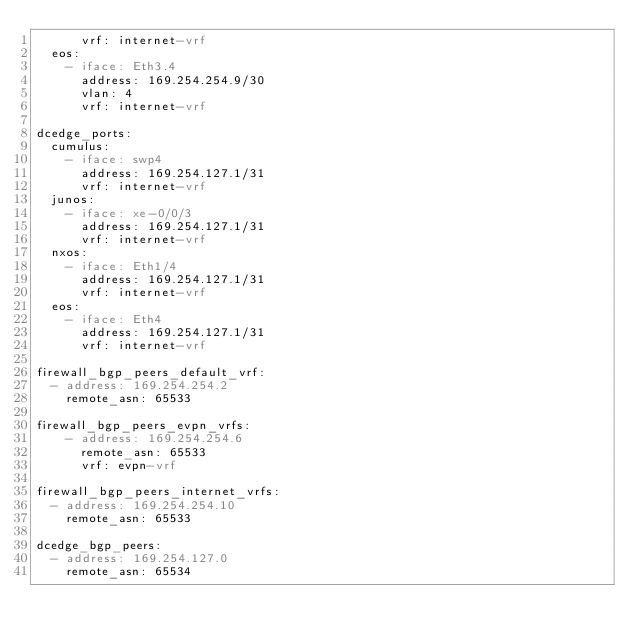<code> <loc_0><loc_0><loc_500><loc_500><_YAML_>      vrf: internet-vrf
  eos:
    - iface: Eth3.4
      address: 169.254.254.9/30
      vlan: 4
      vrf: internet-vrf

dcedge_ports:
  cumulus:
    - iface: swp4
      address: 169.254.127.1/31
      vrf: internet-vrf
  junos:
    - iface: xe-0/0/3
      address: 169.254.127.1/31
      vrf: internet-vrf
  nxos:
    - iface: Eth1/4
      address: 169.254.127.1/31
      vrf: internet-vrf
  eos:
    - iface: Eth4
      address: 169.254.127.1/31
      vrf: internet-vrf

firewall_bgp_peers_default_vrf:
  - address: 169.254.254.2
    remote_asn: 65533

firewall_bgp_peers_evpn_vrfs:
    - address: 169.254.254.6
      remote_asn: 65533
      vrf: evpn-vrf

firewall_bgp_peers_internet_vrfs:
  - address: 169.254.254.10
    remote_asn: 65533

dcedge_bgp_peers:
  - address: 169.254.127.0
    remote_asn: 65534
</code> 